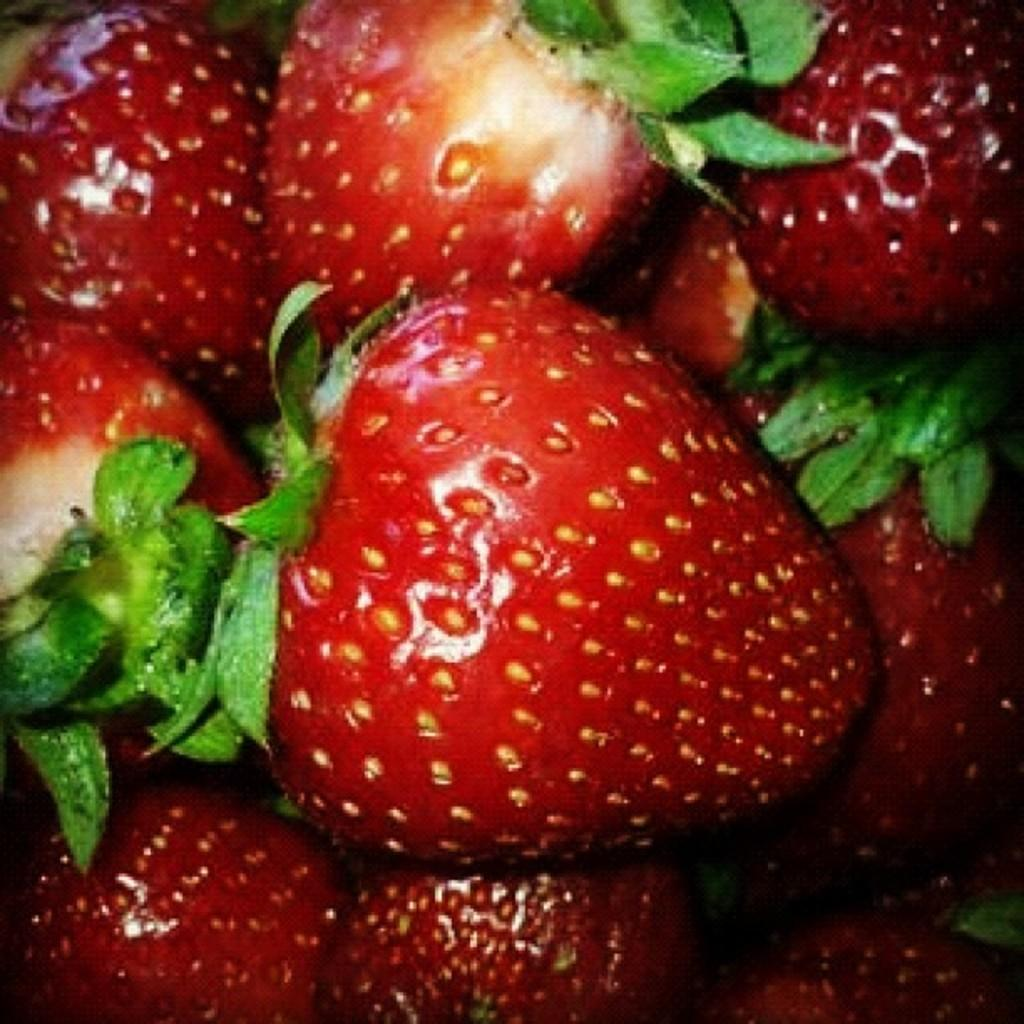What type of fruit is present in the image? The image contains strawberries. What type of ant can be seen leading an army in the image? There are no ants or armies present in the image; it features strawberries. What is the air quality like in the image? The image does not provide any information about the air quality; it only shows strawberries. 